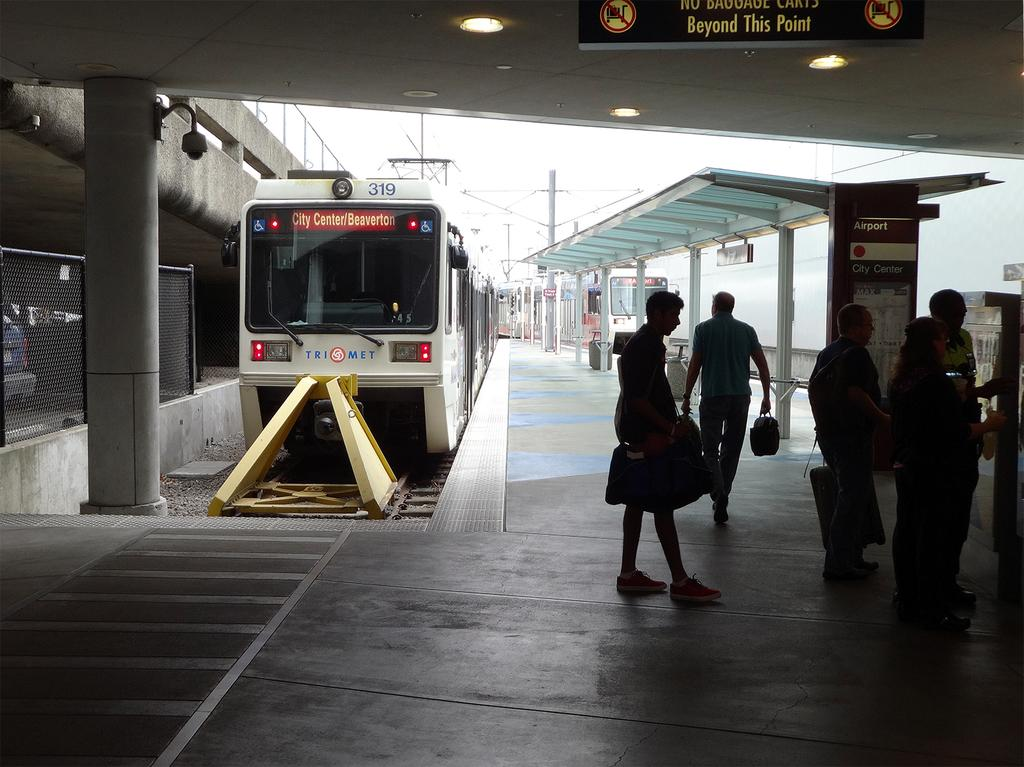<image>
Give a short and clear explanation of the subsequent image. A dark picture of a train station with people standing below a warning sign while a train parked that has arrived at Beaverton city centre sits behind them. 